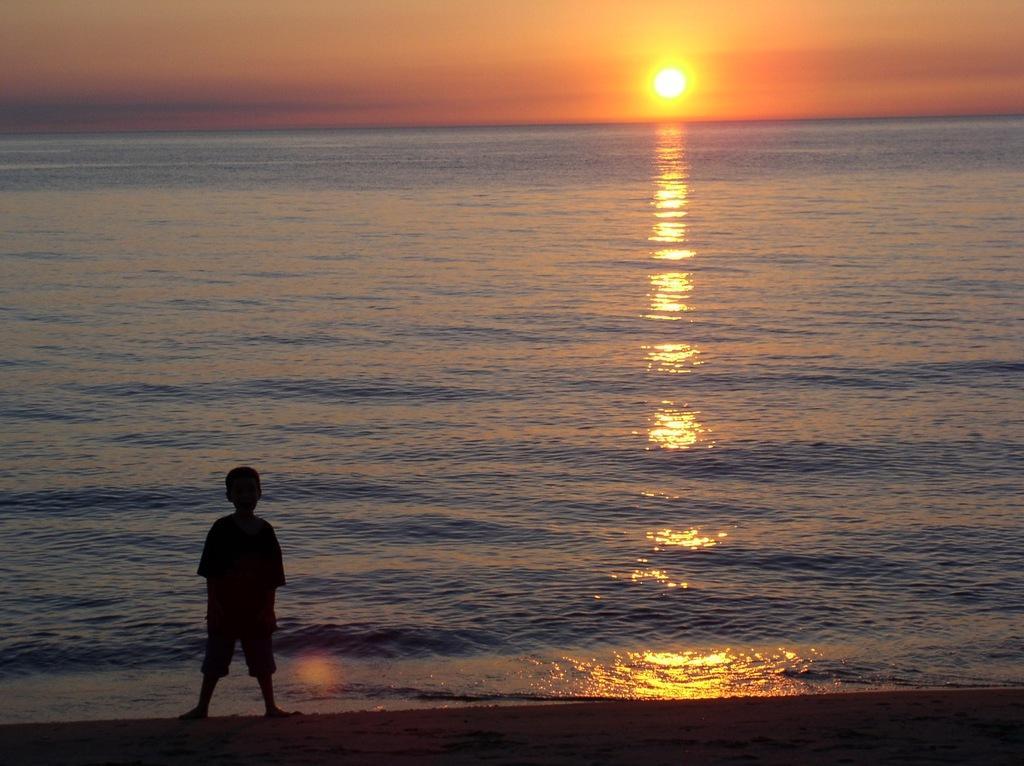Could you give a brief overview of what you see in this image? In this image we can see a kid standing on the ground at the water. In the background we can see sun and clouds in the sky. 